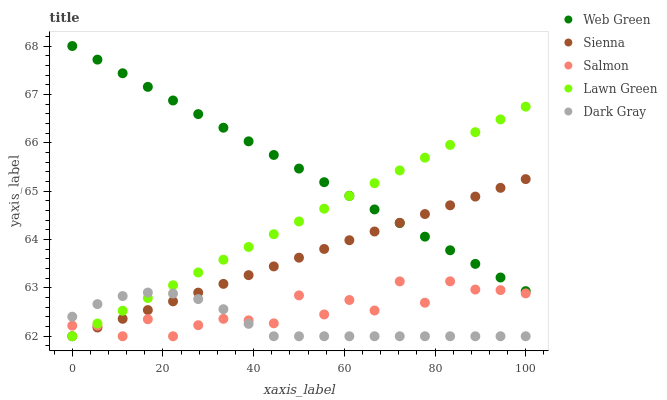Does Dark Gray have the minimum area under the curve?
Answer yes or no. Yes. Does Web Green have the maximum area under the curve?
Answer yes or no. Yes. Does Lawn Green have the minimum area under the curve?
Answer yes or no. No. Does Lawn Green have the maximum area under the curve?
Answer yes or no. No. Is Web Green the smoothest?
Answer yes or no. Yes. Is Salmon the roughest?
Answer yes or no. Yes. Is Lawn Green the smoothest?
Answer yes or no. No. Is Lawn Green the roughest?
Answer yes or no. No. Does Sienna have the lowest value?
Answer yes or no. Yes. Does Web Green have the lowest value?
Answer yes or no. No. Does Web Green have the highest value?
Answer yes or no. Yes. Does Lawn Green have the highest value?
Answer yes or no. No. Is Salmon less than Web Green?
Answer yes or no. Yes. Is Web Green greater than Salmon?
Answer yes or no. Yes. Does Web Green intersect Sienna?
Answer yes or no. Yes. Is Web Green less than Sienna?
Answer yes or no. No. Is Web Green greater than Sienna?
Answer yes or no. No. Does Salmon intersect Web Green?
Answer yes or no. No. 